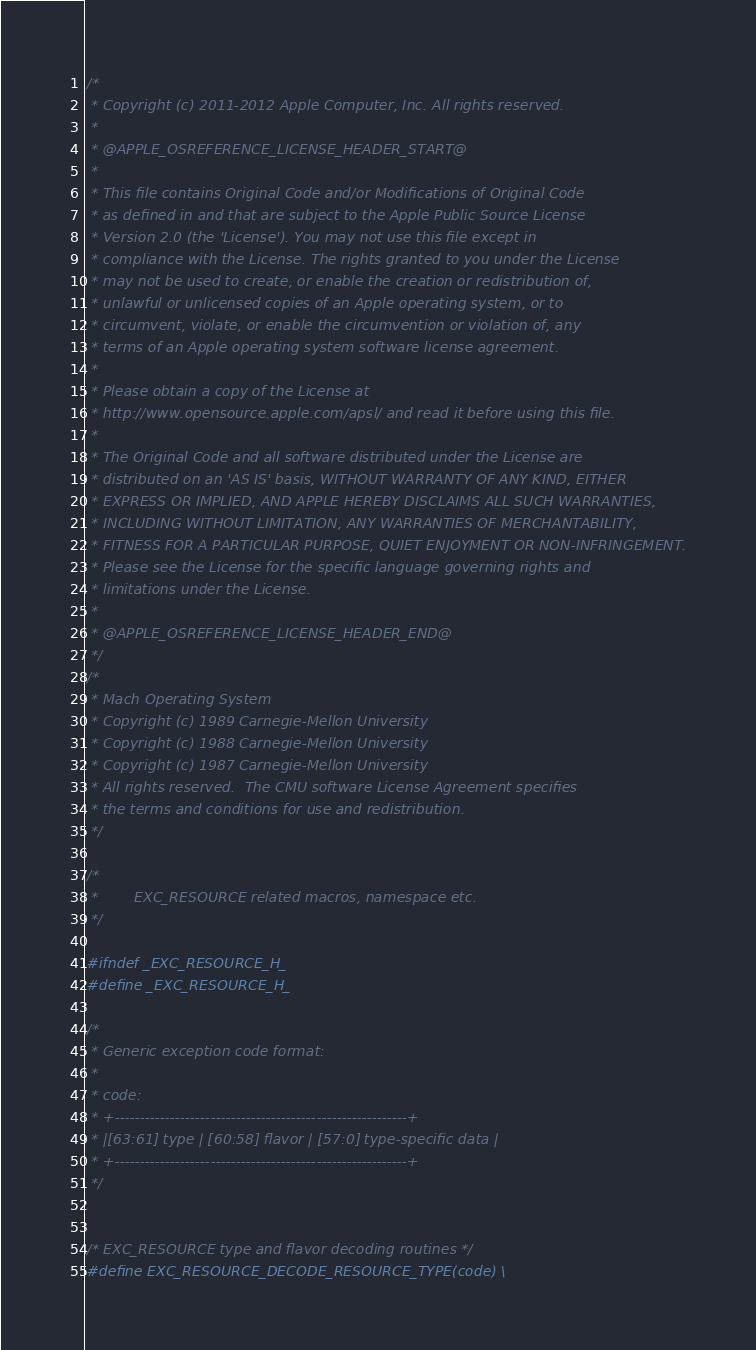<code> <loc_0><loc_0><loc_500><loc_500><_C_>/*
 * Copyright (c) 2011-2012 Apple Computer, Inc. All rights reserved.
 *
 * @APPLE_OSREFERENCE_LICENSE_HEADER_START@
 * 
 * This file contains Original Code and/or Modifications of Original Code
 * as defined in and that are subject to the Apple Public Source License
 * Version 2.0 (the 'License'). You may not use this file except in
 * compliance with the License. The rights granted to you under the License
 * may not be used to create, or enable the creation or redistribution of,
 * unlawful or unlicensed copies of an Apple operating system, or to
 * circumvent, violate, or enable the circumvention or violation of, any
 * terms of an Apple operating system software license agreement.
 * 
 * Please obtain a copy of the License at
 * http://www.opensource.apple.com/apsl/ and read it before using this file.
 * 
 * The Original Code and all software distributed under the License are
 * distributed on an 'AS IS' basis, WITHOUT WARRANTY OF ANY KIND, EITHER
 * EXPRESS OR IMPLIED, AND APPLE HEREBY DISCLAIMS ALL SUCH WARRANTIES,
 * INCLUDING WITHOUT LIMITATION, ANY WARRANTIES OF MERCHANTABILITY,
 * FITNESS FOR A PARTICULAR PURPOSE, QUIET ENJOYMENT OR NON-INFRINGEMENT.
 * Please see the License for the specific language governing rights and
 * limitations under the License.
 * 
 * @APPLE_OSREFERENCE_LICENSE_HEADER_END@
 */
/* 
 * Mach Operating System
 * Copyright (c) 1989 Carnegie-Mellon University
 * Copyright (c) 1988 Carnegie-Mellon University
 * Copyright (c) 1987 Carnegie-Mellon University
 * All rights reserved.  The CMU software License Agreement specifies
 * the terms and conditions for use and redistribution.
 */

/*
 *        EXC_RESOURCE related macros, namespace etc.
 */

#ifndef _EXC_RESOURCE_H_
#define _EXC_RESOURCE_H_

/*
 * Generic exception code format:
 *
 * code:
 * +----------------------------------------------------------+
 * |[63:61] type | [60:58] flavor | [57:0] type-specific data |
 * +----------------------------------------------------------+
 */


/* EXC_RESOURCE type and flavor decoding routines */
#define EXC_RESOURCE_DECODE_RESOURCE_TYPE(code) \</code> 